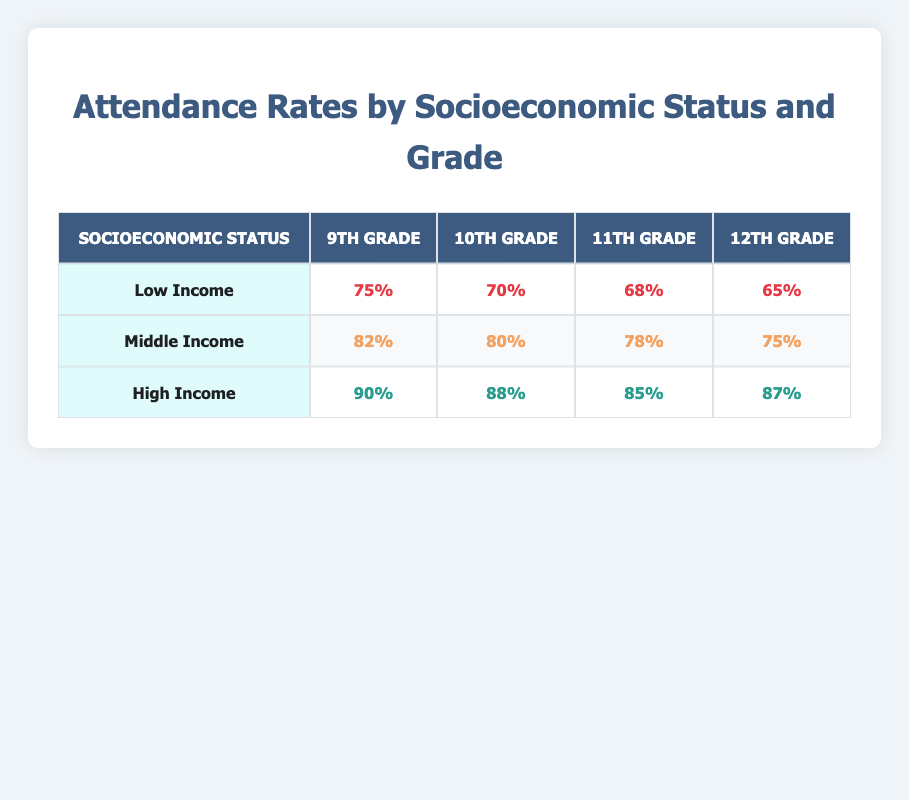What is the attendance rate for 10th graders from low-income households? The table shows the attendance rates for each grade across different socioeconomic statuses. For 10th grade under the "Low Income" category, the attendance rate is 70%.
Answer: 70% What is the attendance rate for 12th graders from high-income households? Looking at the "High Income" row, the attendance rate for 12th graders is listed as 87%.
Answer: 87% Is the attendance rate for 11th graders higher in middle-income households than in low-income households? For middle-income households, the attendance rate for 11th graders is 78%, while for low-income households it is 68%. Since 78 is greater than 68, the attendance rate for middle-income households is higher.
Answer: Yes What is the average attendance rate for 9th graders across all socioeconomic statuses? The attendance rates for 9th graders are 75% (Low Income), 82% (Middle Income), and 90% (High Income). Summing these rates gives 75 + 82 + 90 = 247. There are three data points, so the average is 247/3 = 82.33%.
Answer: 82.33% Is it true that the attendance rate for low-income 12th graders is the lowest among all socioeconomic groups and grades? The attendance rate for low-income 12th graders is 65%. Comparing this with all other attendance rates, 65 is indeed the lowest value present in the table.
Answer: Yes Which grade has the highest attendance rate among middle-income students? From the middle-income row: 9th grade has 82%, 10th grade has 80%, 11th grade 78%, and 12th grade has 75%. The highest attendance rate among these is 82% for 9th graders.
Answer: 9th grade What is the difference in attendance rates between high-income 9th graders and low-income 11th graders? The attendance rate for high-income 9th graders is 90%, and for low-income 11th graders, it is 68%. The difference is 90 - 68 = 22%.
Answer: 22% Which socioeconomic group has the lowest overall attendance in 12th grade? For 12th graders, low-income has an attendance rate of 65%, middle-income has 75%, and high-income has 87%. The lowest rate among these is 65% from the low-income group.
Answer: Low Income How does the attendance rate for 10th graders in high-income households compare to that of low-income households? The table states that the attendance rate for high-income 10th graders is 88%, while for low-income 10th graders, it is 70%. Comparatively, 88 is greater than 70.
Answer: Higher 